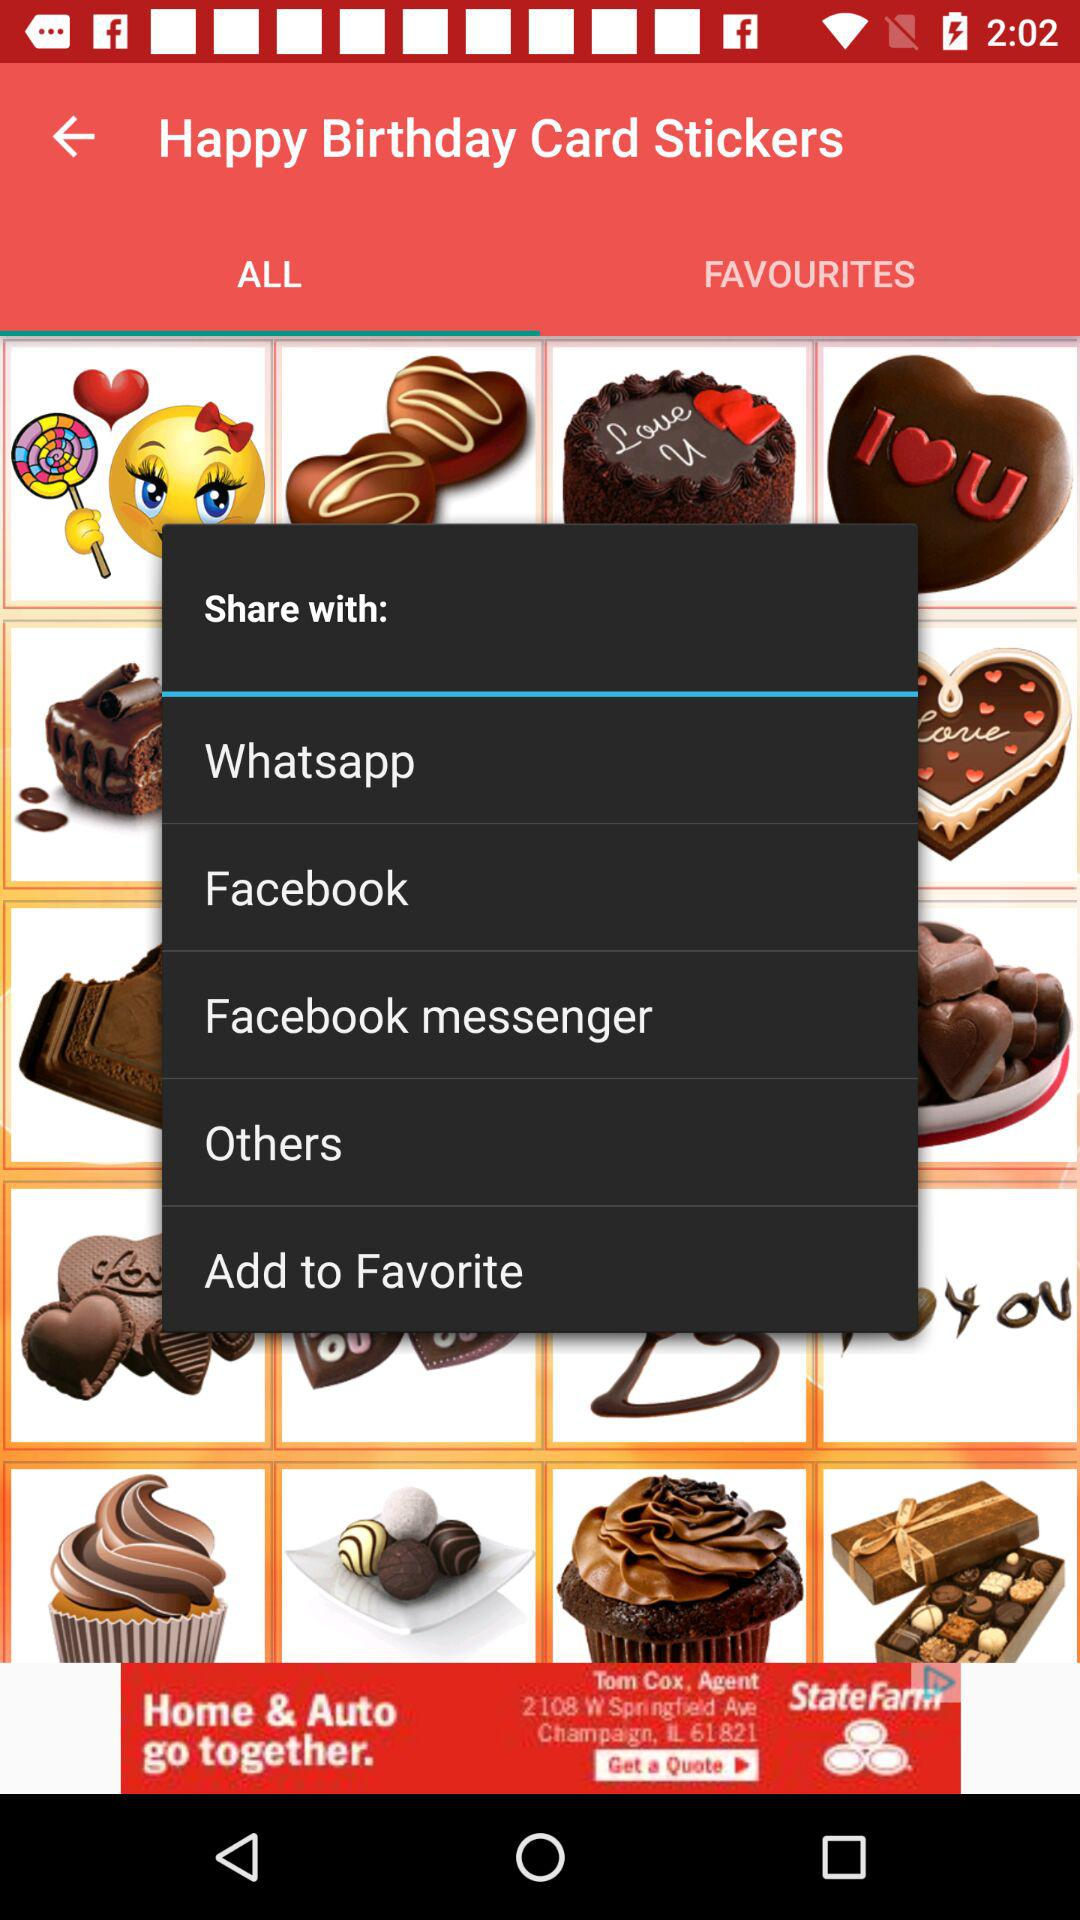What are the options to share with? The options to share with are "Whatsapp", "Facebook", "Facebook messenger", "Others" and "Add to Favorite". 